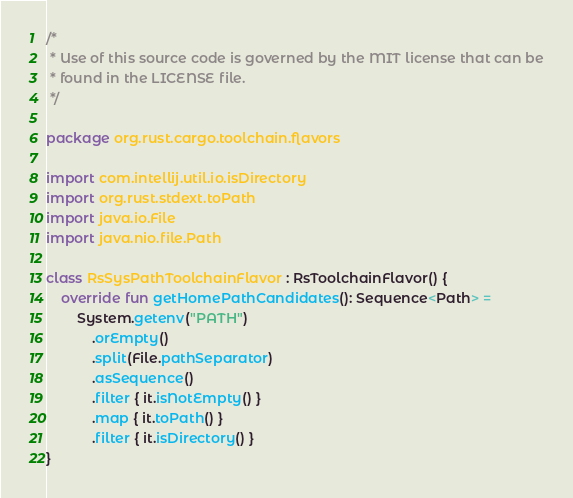Convert code to text. <code><loc_0><loc_0><loc_500><loc_500><_Kotlin_>/*
 * Use of this source code is governed by the MIT license that can be
 * found in the LICENSE file.
 */

package org.rust.cargo.toolchain.flavors

import com.intellij.util.io.isDirectory
import org.rust.stdext.toPath
import java.io.File
import java.nio.file.Path

class RsSysPathToolchainFlavor : RsToolchainFlavor() {
    override fun getHomePathCandidates(): Sequence<Path> =
        System.getenv("PATH")
            .orEmpty()
            .split(File.pathSeparator)
            .asSequence()
            .filter { it.isNotEmpty() }
            .map { it.toPath() }
            .filter { it.isDirectory() }
}
</code> 